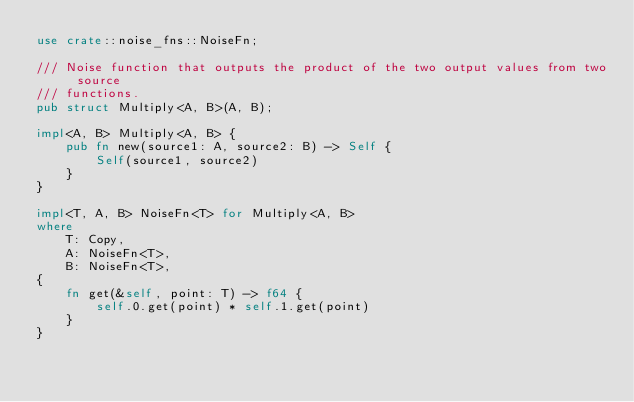<code> <loc_0><loc_0><loc_500><loc_500><_Rust_>use crate::noise_fns::NoiseFn;

/// Noise function that outputs the product of the two output values from two source
/// functions.
pub struct Multiply<A, B>(A, B);

impl<A, B> Multiply<A, B> {
    pub fn new(source1: A, source2: B) -> Self {
        Self(source1, source2)
    }
}

impl<T, A, B> NoiseFn<T> for Multiply<A, B>
where
    T: Copy,
    A: NoiseFn<T>,
    B: NoiseFn<T>,
{
    fn get(&self, point: T) -> f64 {
        self.0.get(point) * self.1.get(point)
    }
}
</code> 